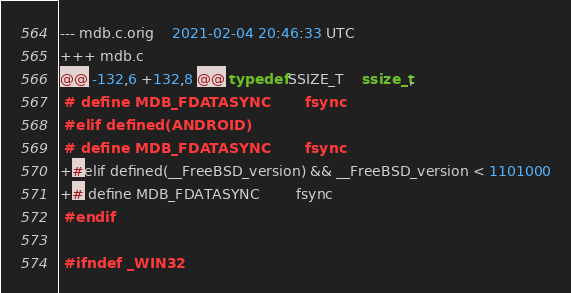Convert code to text. <code><loc_0><loc_0><loc_500><loc_500><_C_>--- mdb.c.orig	2021-02-04 20:46:33 UTC
+++ mdb.c
@@ -132,6 +132,8 @@ typedef SSIZE_T	ssize_t;
 # define MDB_FDATASYNC		fsync
 #elif defined(ANDROID)
 # define MDB_FDATASYNC		fsync
+#elif defined(__FreeBSD_version) && __FreeBSD_version < 1101000
+# define MDB_FDATASYNC		fsync
 #endif
 
 #ifndef _WIN32
</code> 